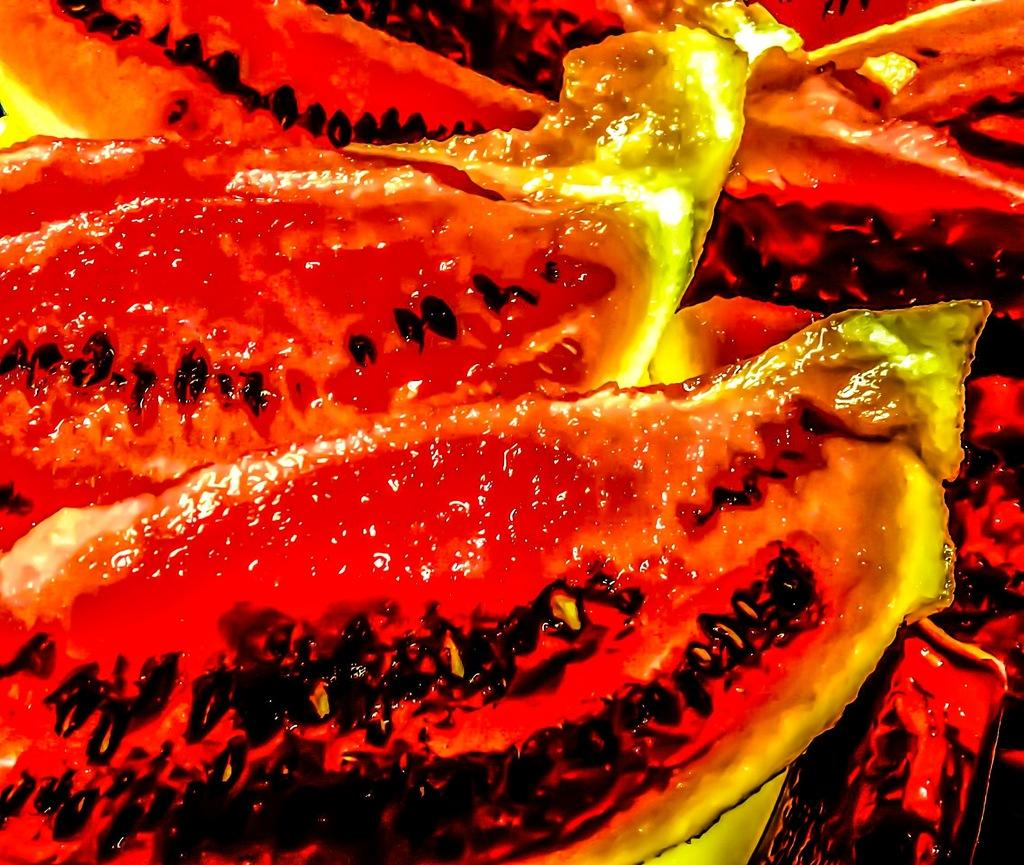What type of food item is present in the image? The image contains a food item, but the specific type is not mentioned in the facts. Can you describe the colors of the food item in the image? Yes, the food item has the colors red, black, yellow, and orange. What is the name of the gate in the image? There is no gate present in the image, as it only contains a food item. Can you describe the facial expression of the food item in the image? The food item does not have a face or any facial expression, as it is an inanimate object. 